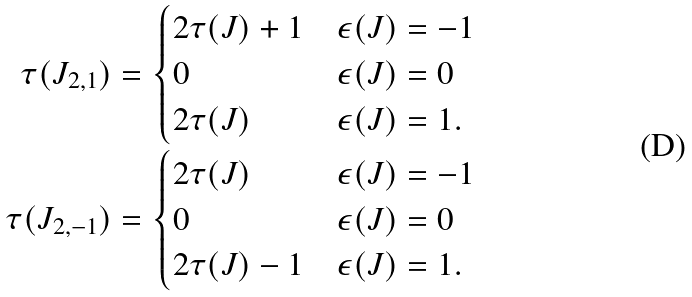Convert formula to latex. <formula><loc_0><loc_0><loc_500><loc_500>\tau ( J _ { 2 , 1 } ) & = \begin{cases} 2 \tau ( J ) + 1 & \epsilon ( J ) = - 1 \\ 0 & \epsilon ( J ) = 0 \\ 2 \tau ( J ) & \epsilon ( J ) = 1 . \end{cases} \\ \tau ( J _ { 2 , - 1 } ) & = \begin{cases} 2 \tau ( J ) & \epsilon ( J ) = - 1 \\ 0 & \epsilon ( J ) = 0 \\ 2 \tau ( J ) - 1 & \epsilon ( J ) = 1 . \end{cases}</formula> 